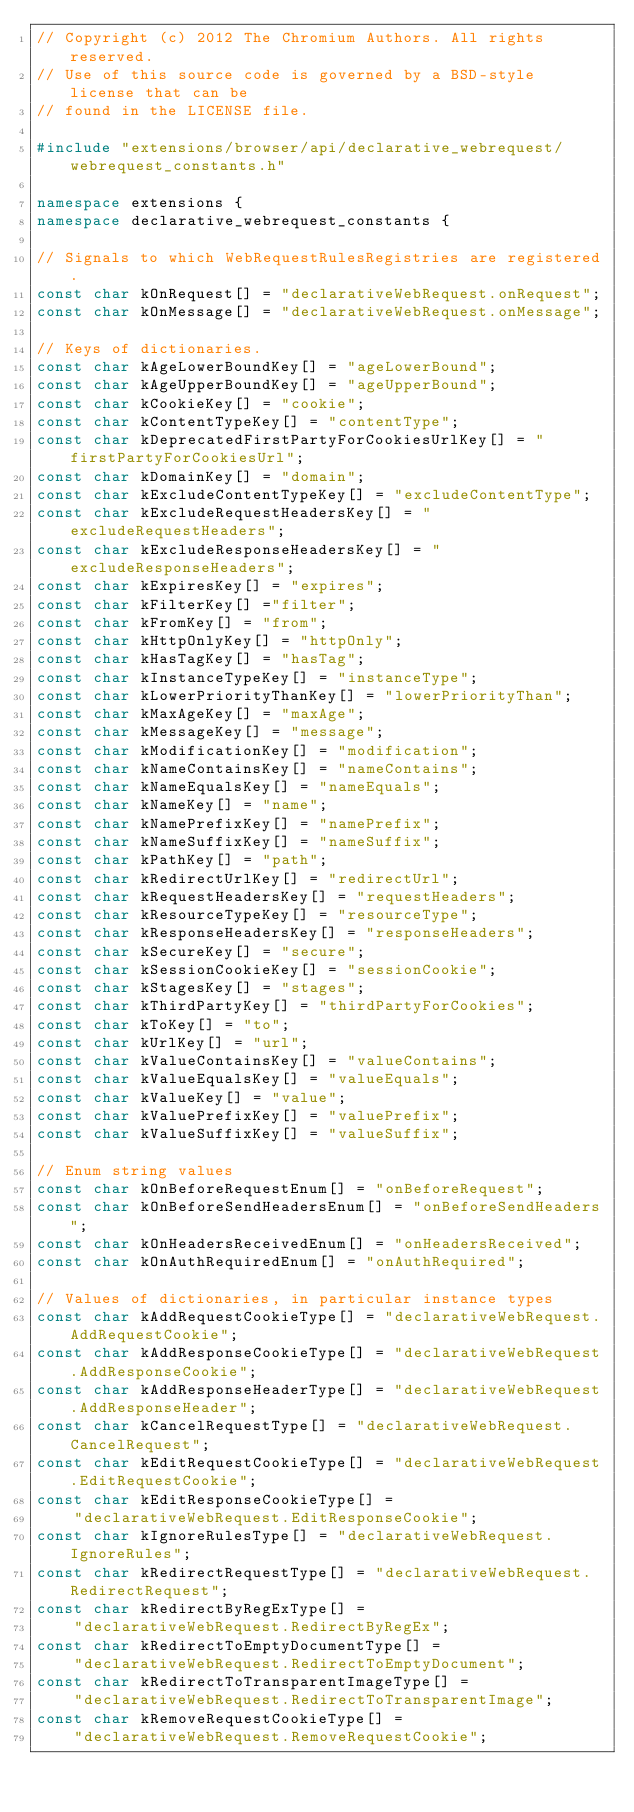<code> <loc_0><loc_0><loc_500><loc_500><_C++_>// Copyright (c) 2012 The Chromium Authors. All rights reserved.
// Use of this source code is governed by a BSD-style license that can be
// found in the LICENSE file.

#include "extensions/browser/api/declarative_webrequest/webrequest_constants.h"

namespace extensions {
namespace declarative_webrequest_constants {

// Signals to which WebRequestRulesRegistries are registered.
const char kOnRequest[] = "declarativeWebRequest.onRequest";
const char kOnMessage[] = "declarativeWebRequest.onMessage";

// Keys of dictionaries.
const char kAgeLowerBoundKey[] = "ageLowerBound";
const char kAgeUpperBoundKey[] = "ageUpperBound";
const char kCookieKey[] = "cookie";
const char kContentTypeKey[] = "contentType";
const char kDeprecatedFirstPartyForCookiesUrlKey[] = "firstPartyForCookiesUrl";
const char kDomainKey[] = "domain";
const char kExcludeContentTypeKey[] = "excludeContentType";
const char kExcludeRequestHeadersKey[] = "excludeRequestHeaders";
const char kExcludeResponseHeadersKey[] = "excludeResponseHeaders";
const char kExpiresKey[] = "expires";
const char kFilterKey[] ="filter";
const char kFromKey[] = "from";
const char kHttpOnlyKey[] = "httpOnly";
const char kHasTagKey[] = "hasTag";
const char kInstanceTypeKey[] = "instanceType";
const char kLowerPriorityThanKey[] = "lowerPriorityThan";
const char kMaxAgeKey[] = "maxAge";
const char kMessageKey[] = "message";
const char kModificationKey[] = "modification";
const char kNameContainsKey[] = "nameContains";
const char kNameEqualsKey[] = "nameEquals";
const char kNameKey[] = "name";
const char kNamePrefixKey[] = "namePrefix";
const char kNameSuffixKey[] = "nameSuffix";
const char kPathKey[] = "path";
const char kRedirectUrlKey[] = "redirectUrl";
const char kRequestHeadersKey[] = "requestHeaders";
const char kResourceTypeKey[] = "resourceType";
const char kResponseHeadersKey[] = "responseHeaders";
const char kSecureKey[] = "secure";
const char kSessionCookieKey[] = "sessionCookie";
const char kStagesKey[] = "stages";
const char kThirdPartyKey[] = "thirdPartyForCookies";
const char kToKey[] = "to";
const char kUrlKey[] = "url";
const char kValueContainsKey[] = "valueContains";
const char kValueEqualsKey[] = "valueEquals";
const char kValueKey[] = "value";
const char kValuePrefixKey[] = "valuePrefix";
const char kValueSuffixKey[] = "valueSuffix";

// Enum string values
const char kOnBeforeRequestEnum[] = "onBeforeRequest";
const char kOnBeforeSendHeadersEnum[] = "onBeforeSendHeaders";
const char kOnHeadersReceivedEnum[] = "onHeadersReceived";
const char kOnAuthRequiredEnum[] = "onAuthRequired";

// Values of dictionaries, in particular instance types
const char kAddRequestCookieType[] = "declarativeWebRequest.AddRequestCookie";
const char kAddResponseCookieType[] = "declarativeWebRequest.AddResponseCookie";
const char kAddResponseHeaderType[] = "declarativeWebRequest.AddResponseHeader";
const char kCancelRequestType[] = "declarativeWebRequest.CancelRequest";
const char kEditRequestCookieType[] = "declarativeWebRequest.EditRequestCookie";
const char kEditResponseCookieType[] =
    "declarativeWebRequest.EditResponseCookie";
const char kIgnoreRulesType[] = "declarativeWebRequest.IgnoreRules";
const char kRedirectRequestType[] = "declarativeWebRequest.RedirectRequest";
const char kRedirectByRegExType[] =
    "declarativeWebRequest.RedirectByRegEx";
const char kRedirectToEmptyDocumentType[] =
    "declarativeWebRequest.RedirectToEmptyDocument";
const char kRedirectToTransparentImageType[] =
    "declarativeWebRequest.RedirectToTransparentImage";
const char kRemoveRequestCookieType[] =
    "declarativeWebRequest.RemoveRequestCookie";</code> 